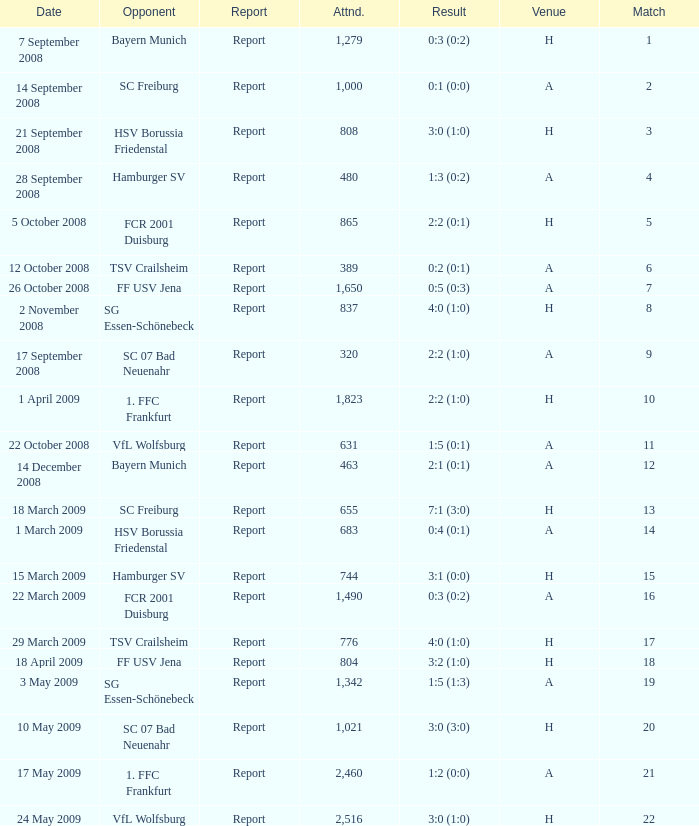Which match had more than 1,490 people in attendance to watch FCR 2001 Duisburg have a result of 0:3 (0:2)? None. 